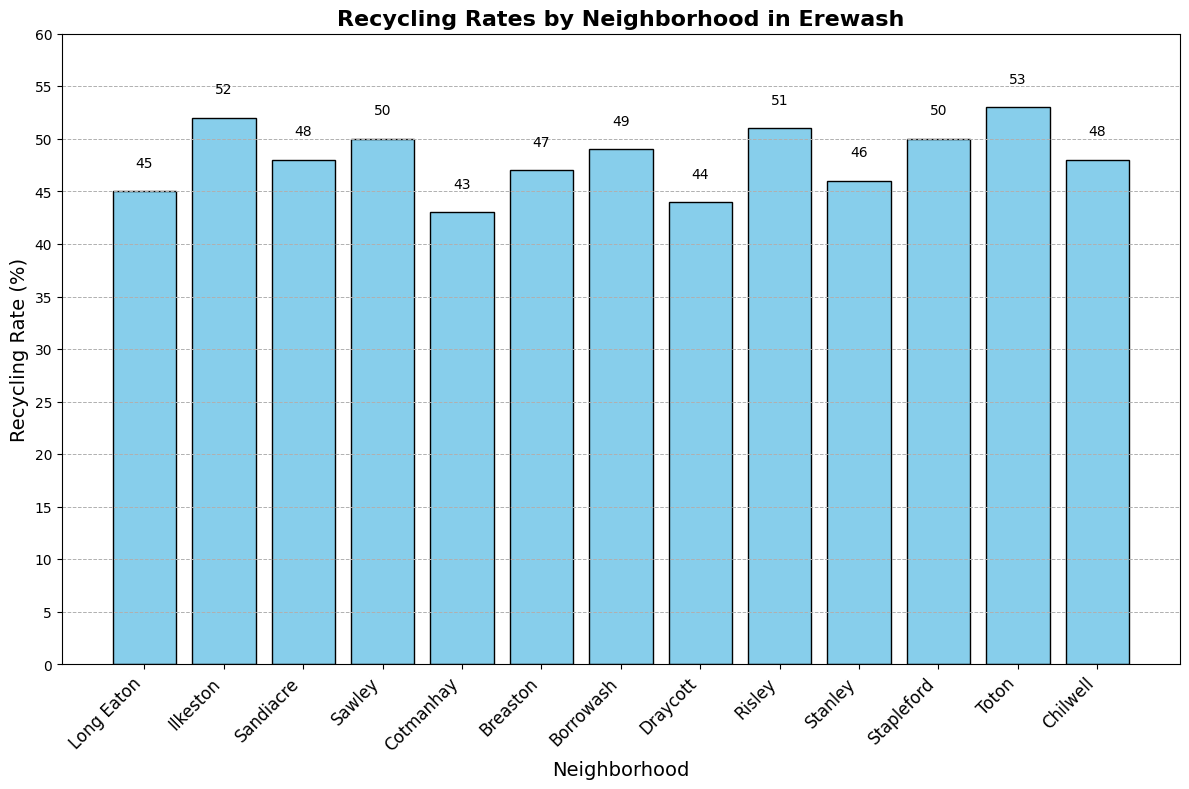Which neighborhood has the highest recycling rate? The bar for Toton is the tallest and is labeled with a recycling rate of 53%.
Answer: Toton What is the average recycling rate of all neighborhoods? Sum the recycling rates of all neighborhoods and divide by the number of neighborhoods: (45+52+48+50+43+47+49+44+51+46+50+53+48) ÷ 13 = 626 ÷ 13 ≈ 48.15
Answer: 48.15 How much higher is the recycling rate in Ilkeston compared to Cotmanhay? Subtract the recycling rate of Cotmanhay (43%) from Ilkeston (52%): 52 - 43 = 9%.
Answer: 9% Which neighborhood has a recycling rate closest to the average rate? Calculate the average recycling rate to be around 48.15%. The neighborhood rates closest to this are Sandiacre (48%) and Chilwell (48%).
Answer: Sandiacre or Chilwell Are there more neighborhoods with recycling rates above 50% or below 50%? Count the neighborhoods above and below 50%. Above: Ilkeston, Sawley, Risley, Toton (4 neighborhoods). Below: Long Eaton, Sandiacre, Cotmanhay, Breaston, Borrowash, Draycott, Stanley, Stapleford, Chilwell (9 neighborhoods).
Answer: Below 50% What is the combined recycling rate of Long Eaton, Ilkeston, and Sandiacre? Add the recycling rates of the three neighborhoods: 45 + 52 + 48 = 145%.
Answer: 145% Which neighborhoods have recycling rates that are directly labeled on the bars as equal to 50%? The bars for Sawley and Stapleford both have labels indicating a recycling rate of 50%.
Answer: Sawley and Stapleford How does the recycling rate of Risley compare to that of Chilwell? The bar for Risley is higher (51%) compared to the bar for Chilwell (48%).
Answer: Higher What is the median recycling rate among all neighborhoods? List the rates in numerical order: 43, 44, 45, 46, 47, 48, 48, 49, 50, 50, 51, 52, 53. The median will be the middle rate: (48+48)/2 = 48%.
Answer: 48% If Breaston increased its recycling rate by 5 percentage points, what would be its new rate? Breaston's current rate is 47%. Adding 5 percentage points: 47 + 5 = 52%.
Answer: 52% 